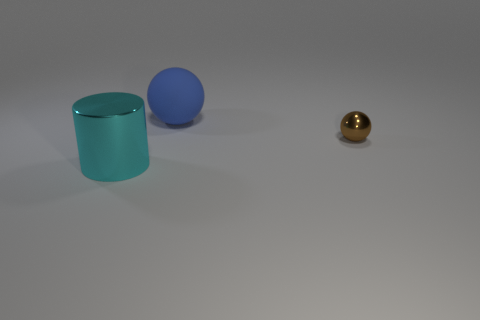Subtract all balls. How many objects are left? 1 Add 3 cyan things. How many objects exist? 6 Add 1 blue balls. How many blue balls are left? 2 Add 2 large blue rubber balls. How many large blue rubber balls exist? 3 Subtract 0 green cylinders. How many objects are left? 3 Subtract all big purple rubber balls. Subtract all blue rubber spheres. How many objects are left? 2 